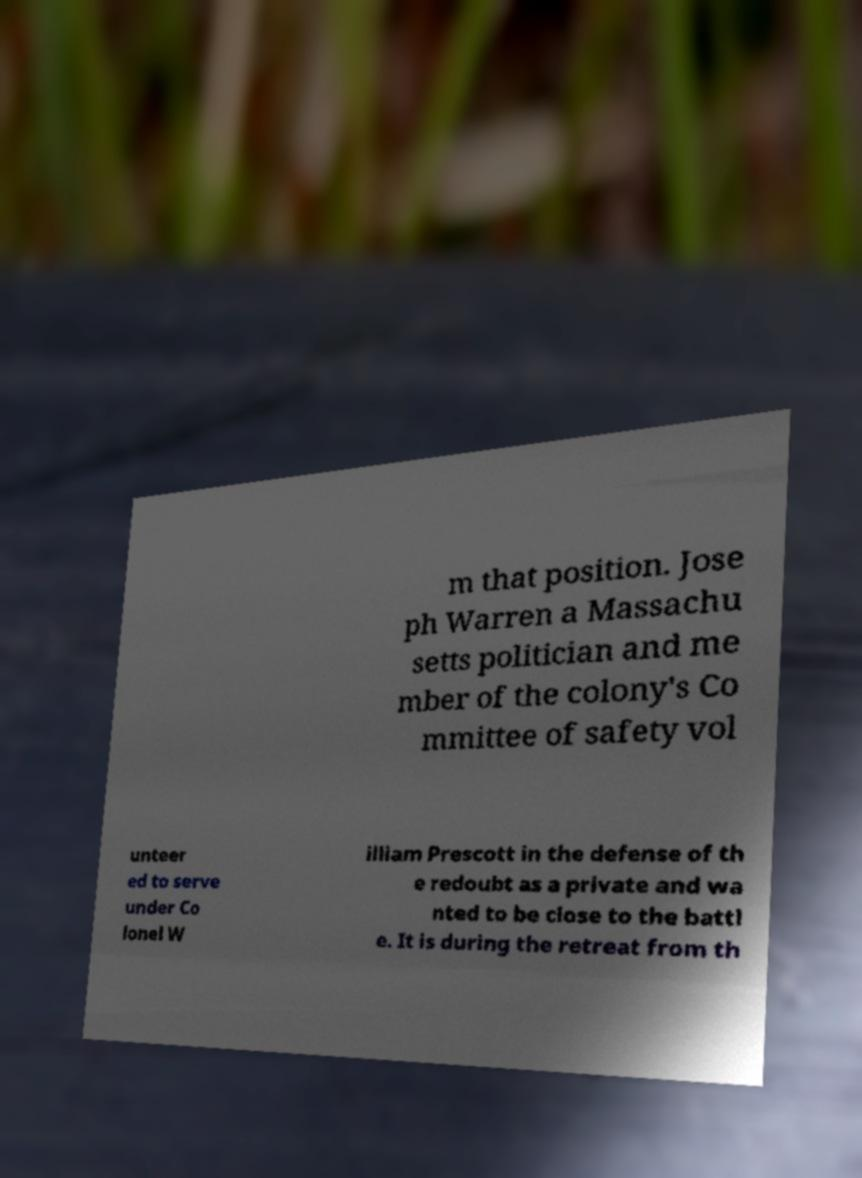I need the written content from this picture converted into text. Can you do that? m that position. Jose ph Warren a Massachu setts politician and me mber of the colony's Co mmittee of safety vol unteer ed to serve under Co lonel W illiam Prescott in the defense of th e redoubt as a private and wa nted to be close to the battl e. It is during the retreat from th 